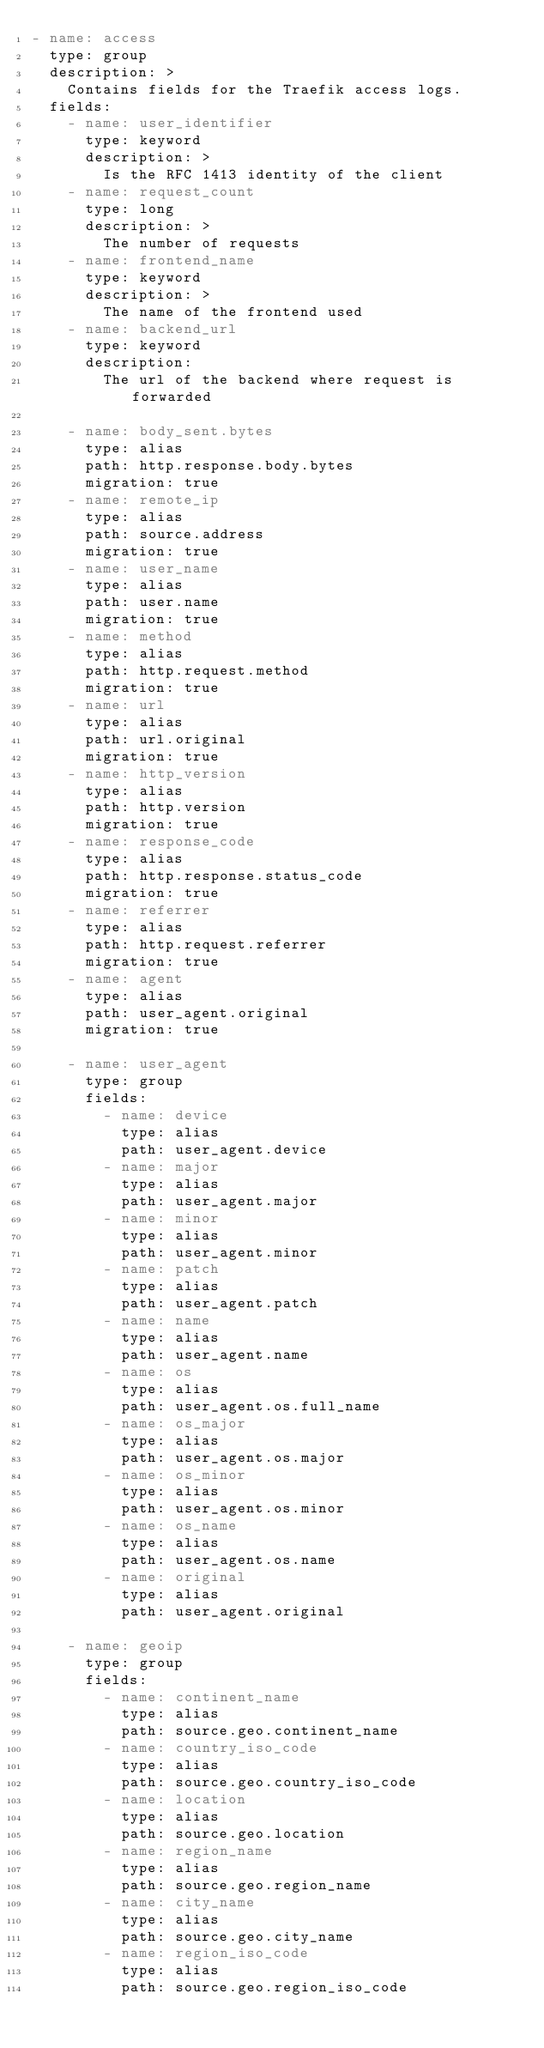<code> <loc_0><loc_0><loc_500><loc_500><_YAML_>- name: access
  type: group
  description: >
    Contains fields for the Traefik access logs.
  fields:
    - name: user_identifier
      type: keyword
      description: >
        Is the RFC 1413 identity of the client
    - name: request_count
      type: long
      description: >
        The number of requests
    - name: frontend_name
      type: keyword
      description: >
        The name of the frontend used
    - name: backend_url
      type: keyword
      description:
        The url of the backend where request is forwarded

    - name: body_sent.bytes
      type: alias
      path: http.response.body.bytes
      migration: true
    - name: remote_ip
      type: alias
      path: source.address
      migration: true
    - name: user_name
      type: alias
      path: user.name
      migration: true
    - name: method
      type: alias
      path: http.request.method
      migration: true
    - name: url
      type: alias
      path: url.original
      migration: true
    - name: http_version
      type: alias
      path: http.version
      migration: true
    - name: response_code
      type: alias
      path: http.response.status_code
      migration: true
    - name: referrer
      type: alias
      path: http.request.referrer
      migration: true
    - name: agent
      type: alias
      path: user_agent.original
      migration: true

    - name: user_agent
      type: group
      fields:
        - name: device
          type: alias
          path: user_agent.device
        - name: major
          type: alias
          path: user_agent.major
        - name: minor
          type: alias
          path: user_agent.minor
        - name: patch
          type: alias
          path: user_agent.patch
        - name: name
          type: alias
          path: user_agent.name
        - name: os
          type: alias
          path: user_agent.os.full_name
        - name: os_major
          type: alias
          path: user_agent.os.major
        - name: os_minor
          type: alias
          path: user_agent.os.minor
        - name: os_name
          type: alias
          path: user_agent.os.name
        - name: original
          type: alias
          path: user_agent.original

    - name: geoip
      type: group
      fields:
        - name: continent_name
          type: alias
          path: source.geo.continent_name
        - name: country_iso_code
          type: alias
          path: source.geo.country_iso_code
        - name: location
          type: alias
          path: source.geo.location
        - name: region_name
          type: alias
          path: source.geo.region_name
        - name: city_name
          type: alias
          path: source.geo.city_name
        - name: region_iso_code
          type: alias
          path: source.geo.region_iso_code

</code> 